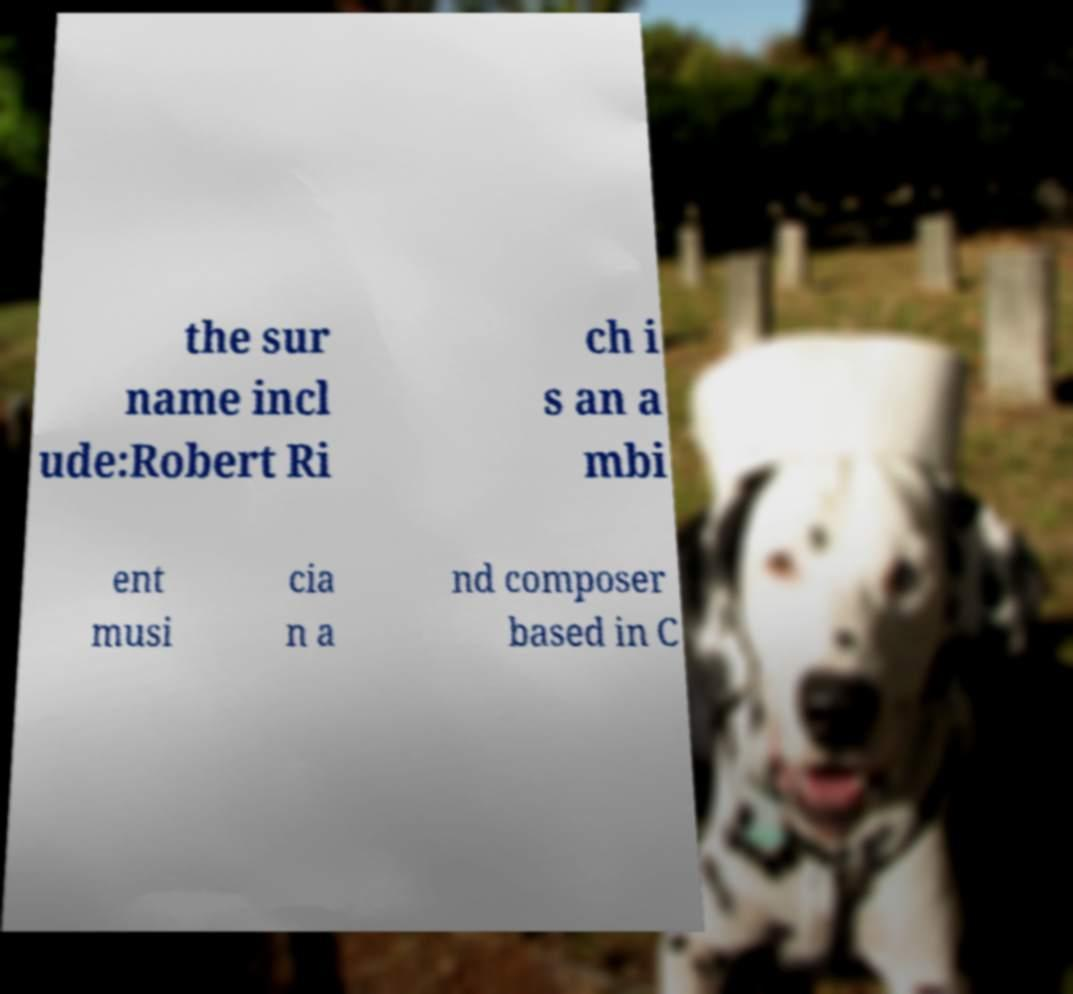I need the written content from this picture converted into text. Can you do that? the sur name incl ude:Robert Ri ch i s an a mbi ent musi cia n a nd composer based in C 